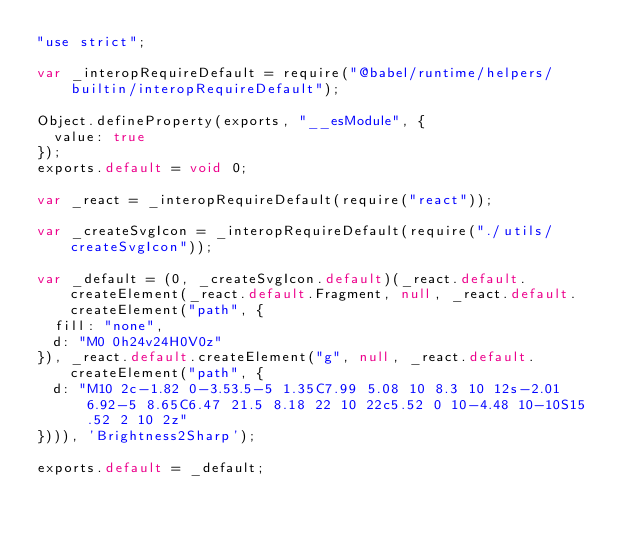Convert code to text. <code><loc_0><loc_0><loc_500><loc_500><_JavaScript_>"use strict";

var _interopRequireDefault = require("@babel/runtime/helpers/builtin/interopRequireDefault");

Object.defineProperty(exports, "__esModule", {
  value: true
});
exports.default = void 0;

var _react = _interopRequireDefault(require("react"));

var _createSvgIcon = _interopRequireDefault(require("./utils/createSvgIcon"));

var _default = (0, _createSvgIcon.default)(_react.default.createElement(_react.default.Fragment, null, _react.default.createElement("path", {
  fill: "none",
  d: "M0 0h24v24H0V0z"
}), _react.default.createElement("g", null, _react.default.createElement("path", {
  d: "M10 2c-1.82 0-3.53.5-5 1.35C7.99 5.08 10 8.3 10 12s-2.01 6.92-5 8.65C6.47 21.5 8.18 22 10 22c5.52 0 10-4.48 10-10S15.52 2 10 2z"
}))), 'Brightness2Sharp');

exports.default = _default;</code> 